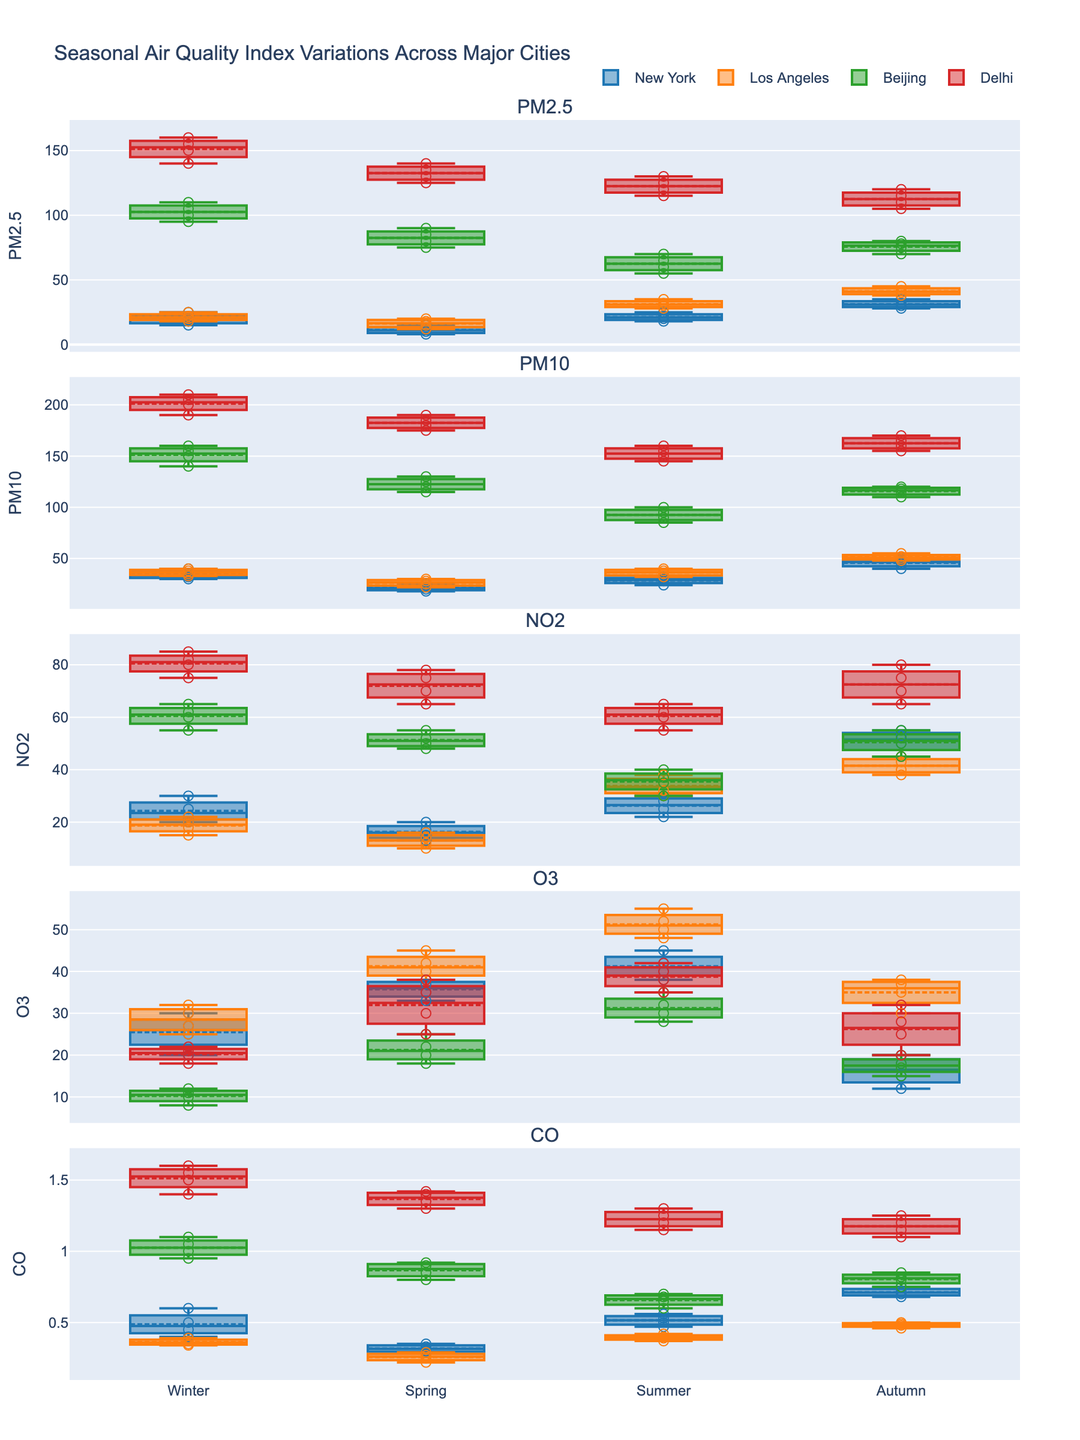Which season shows the highest median PM2.5 level in New York? Look at the median line of the PM2.5 box plots for New York across different seasons. The highest median is in Autumn where the line within the box plot is higher compared to other seasons like Winter, Spring, and Summer.
Answer: Autumn In which city and season is the highest individual PM2.5 reading observed? Check the scatter points for PM2.5 across all cities and seasons. The highest individual reading is seen in Delhi during Winter with the point reaching 160.
Answer: Delhi, Winter How does the median PM10 level in Spring compare between Beijing and Los Angeles? Compare the median lines of the PM10 box plots in Spring for Beijing and Los Angeles. The median line for Beijing's Spring PM10 is at 125, whereas it's around 25 for Los Angeles.
Answer: Higher in Beijing What is the general trend of CO levels in Delhi across the seasons? Observe the CO box plots for Delhi from Winter to Autumn. The median and overall range of CO levels decrease from Winter to Autumn.
Answer: Decreasing Which season has the lowest variability in O3 levels in Beijing? Look at the width of the boxes (interquartile range) for O3 in Beijing across different seasons. Summer has the narrowest box, indicating the lowest variability.
Answer: Summer Among all cities, which had the highest median NO2 level during Autumn? Identify the city by comparing the NO2 box plots during Autumn. Beijing shows the highest median NO2 level as the median line is at 52, higher than other cities.
Answer: Beijing Are there any cities that exhibit lower PM2.5 levels in Autumn compared to Spring? Compare the median lines of PM2.5 for cities in Autumn and Spring. No city has a lower median PM2.5 in Autumn compared to Spring, all increase or remain the same.
Answer: No What is the range of O3 levels during Spring in New York? Check the highest and lowest values represented by the whiskers and scatter points for O3 in Spring for New York. The highest is around 38 and the lowest around 33.
Answer: 33 to 38 How does the winter PM2.5 median in Los Angeles compare with the summer PM2.5 median in the same city? Compare the median lines for PM2.5 in Winter and Summer for Los Angeles. The Winter median is around 35, while the Summer median is 35 as well.
Answer: Equal Which city experiences the greatest seasonal variation in CO levels? Look at the range of box plots for CO for each city across all seasons. Beijing displays the greatest seasonal variation with the highest interquartile ranges and the largest difference between whisker points across seasons.
Answer: Beijing 